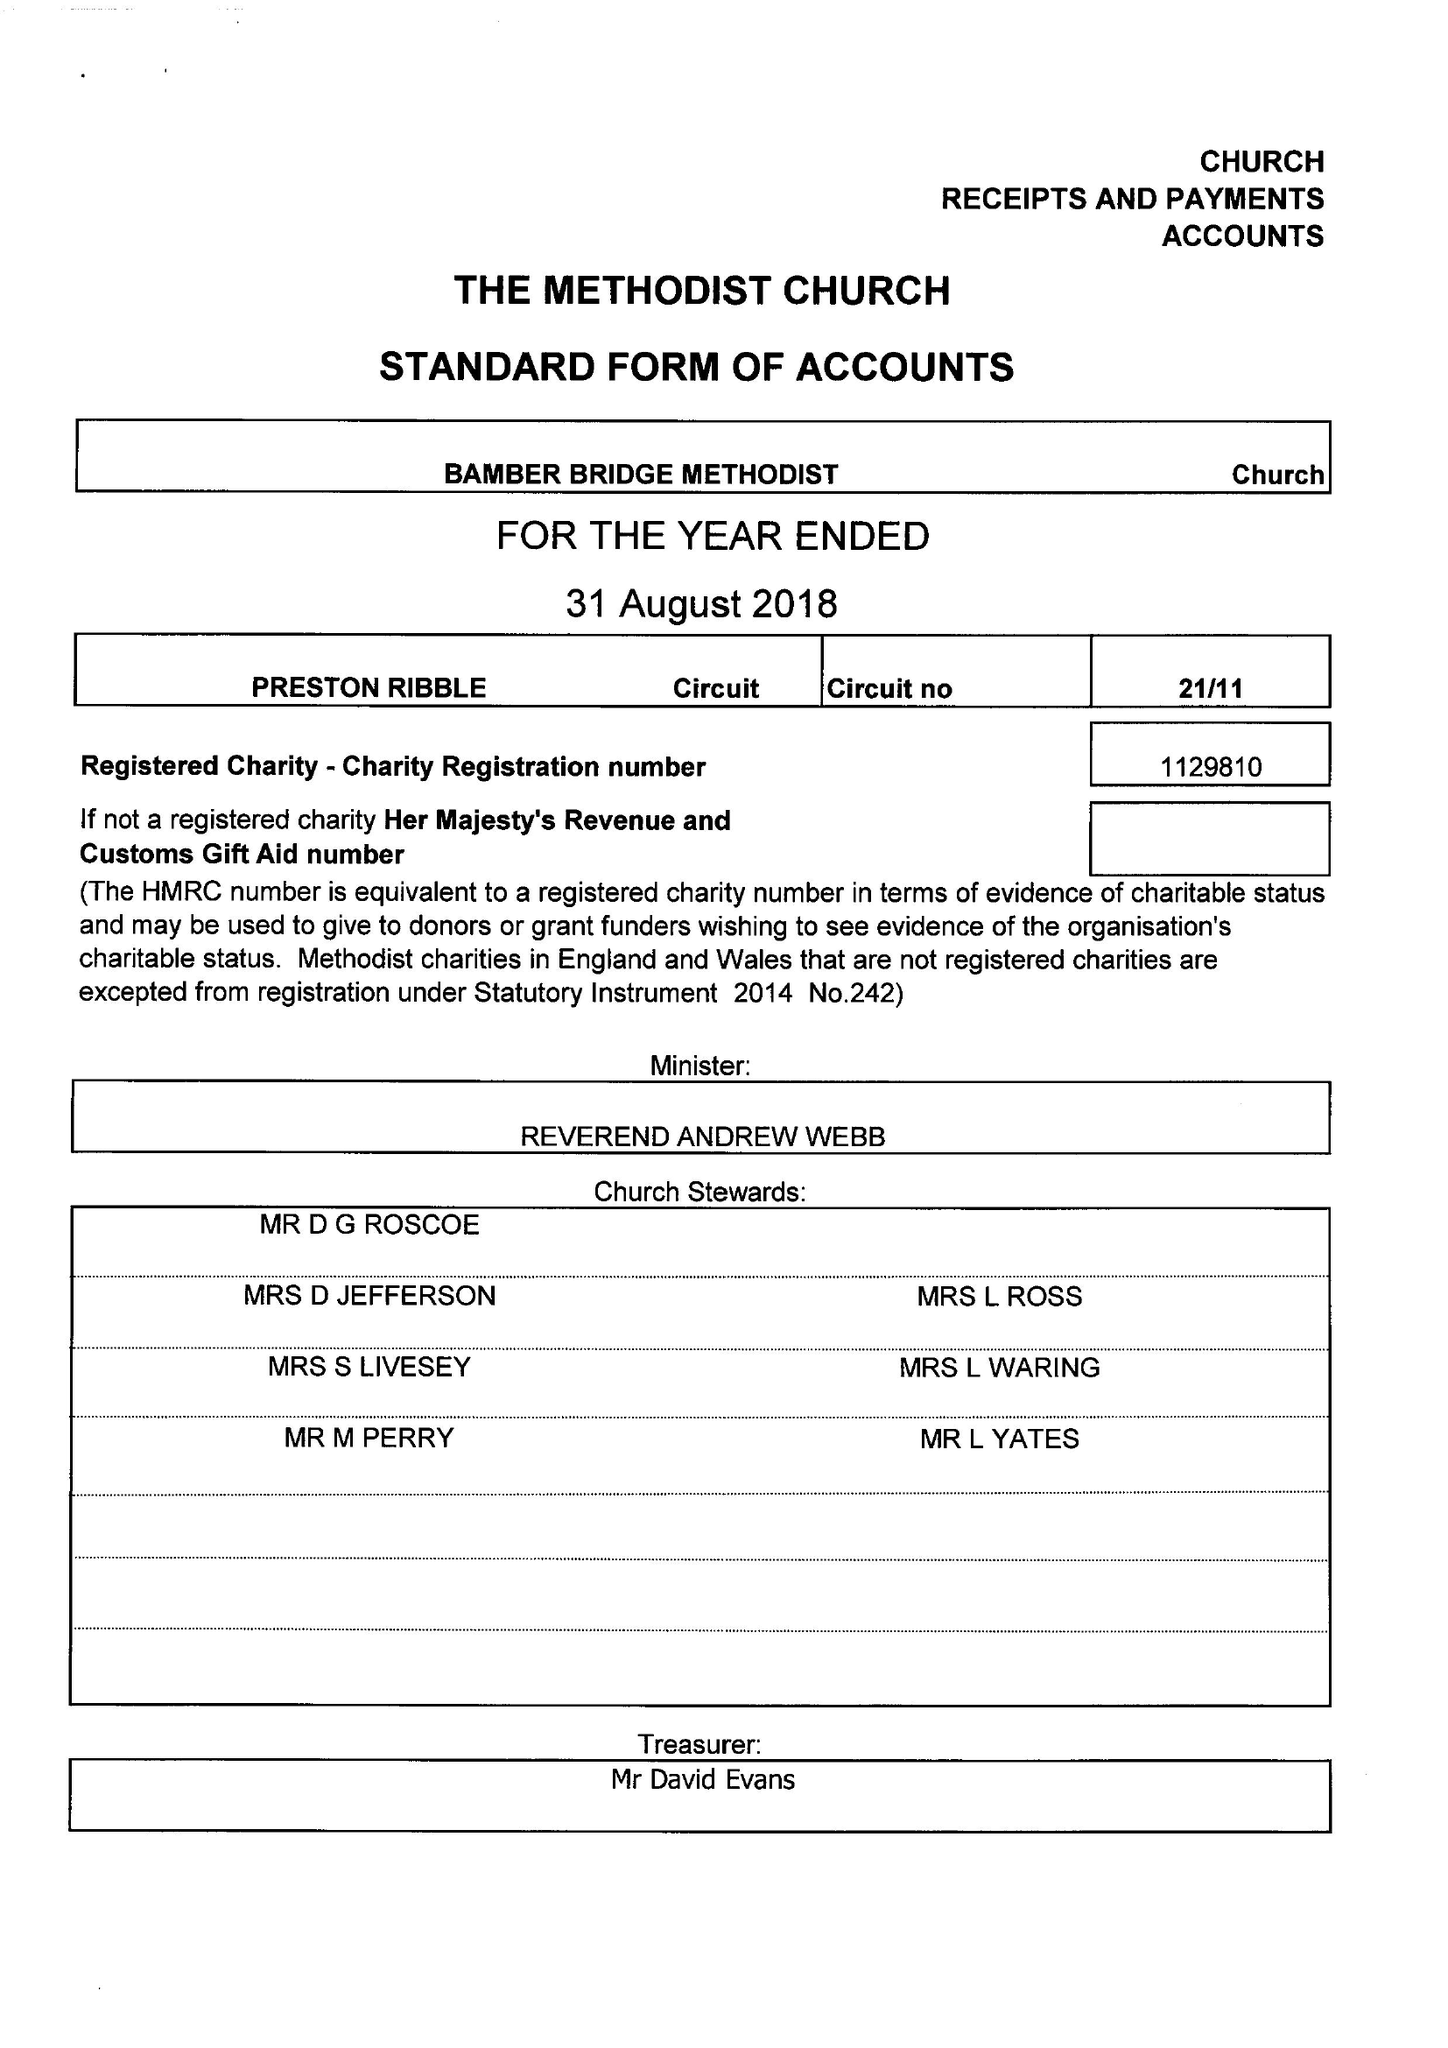What is the value for the spending_annually_in_british_pounds?
Answer the question using a single word or phrase. 75279.00 